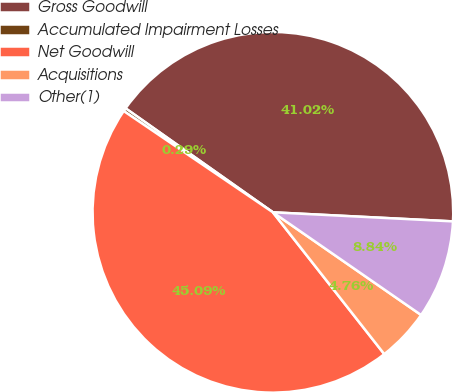<chart> <loc_0><loc_0><loc_500><loc_500><pie_chart><fcel>Gross Goodwill<fcel>Accumulated Impairment Losses<fcel>Net Goodwill<fcel>Acquisitions<fcel>Other(1)<nl><fcel>41.02%<fcel>0.29%<fcel>45.09%<fcel>4.76%<fcel>8.84%<nl></chart> 